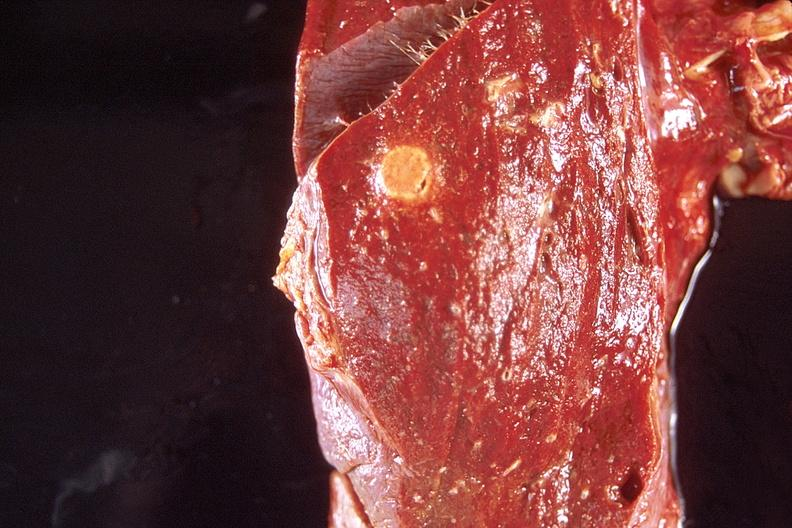does metastatic carcinoma oat cell show lung, diffuse alveolar damage and abscess?
Answer the question using a single word or phrase. No 